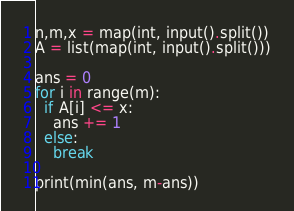Convert code to text. <code><loc_0><loc_0><loc_500><loc_500><_Python_>n,m,x = map(int, input().split())
A = list(map(int, input().split()))

ans = 0
for i in range(m):
  if A[i] <= x:
    ans += 1
  else:
    break
    
print(min(ans, m-ans))
</code> 